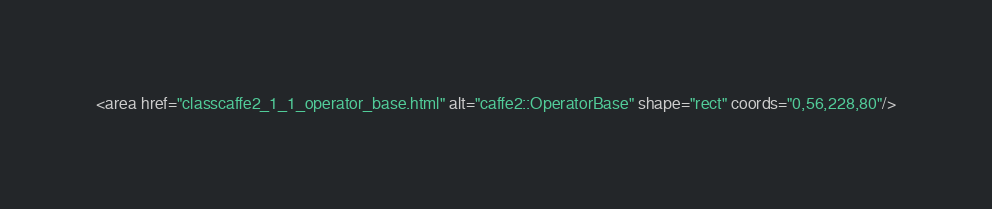Convert code to text. <code><loc_0><loc_0><loc_500><loc_500><_HTML_><area href="classcaffe2_1_1_operator_base.html" alt="caffe2::OperatorBase" shape="rect" coords="0,56,228,80"/></code> 